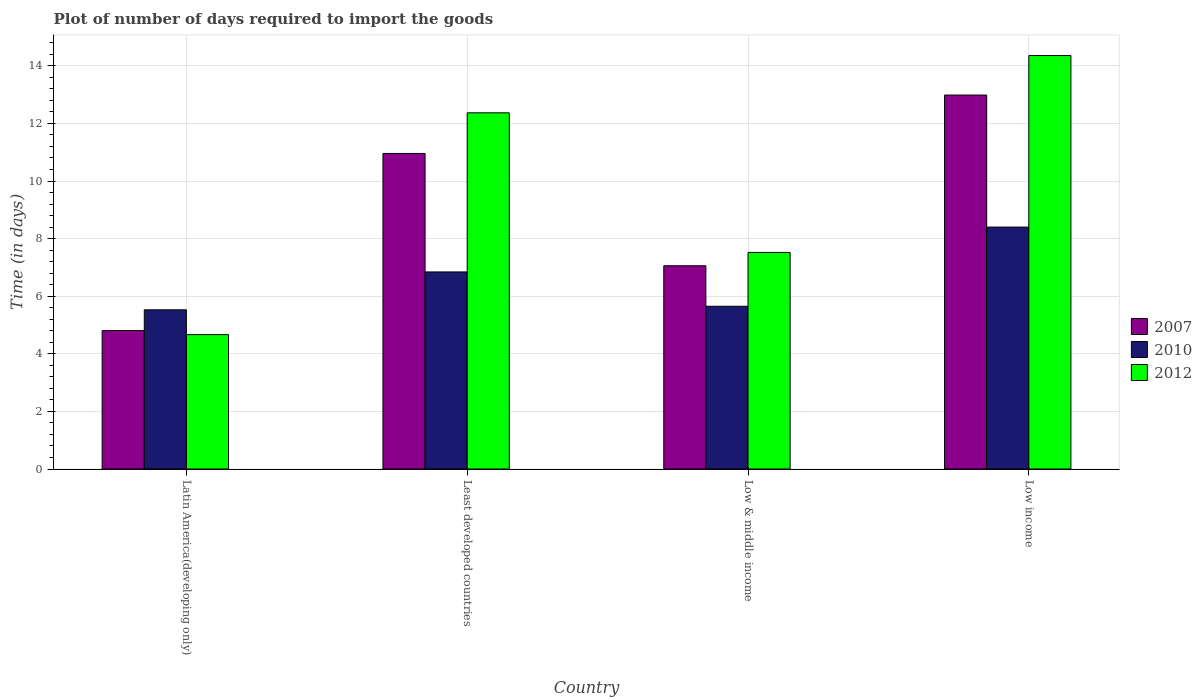How many groups of bars are there?
Your response must be concise. 4. Are the number of bars per tick equal to the number of legend labels?
Offer a very short reply. Yes. How many bars are there on the 4th tick from the left?
Make the answer very short. 3. In how many cases, is the number of bars for a given country not equal to the number of legend labels?
Ensure brevity in your answer.  0. What is the time required to import goods in 2012 in Least developed countries?
Give a very brief answer. 12.37. Across all countries, what is the maximum time required to import goods in 2012?
Keep it short and to the point. 14.36. Across all countries, what is the minimum time required to import goods in 2007?
Your response must be concise. 4.81. In which country was the time required to import goods in 2012 minimum?
Your response must be concise. Latin America(developing only). What is the total time required to import goods in 2012 in the graph?
Keep it short and to the point. 38.91. What is the difference between the time required to import goods in 2007 in Least developed countries and that in Low & middle income?
Your response must be concise. 3.9. What is the difference between the time required to import goods in 2012 in Latin America(developing only) and the time required to import goods in 2010 in Low income?
Give a very brief answer. -3.73. What is the average time required to import goods in 2010 per country?
Give a very brief answer. 6.61. What is the difference between the time required to import goods of/in 2007 and time required to import goods of/in 2012 in Low income?
Your answer should be very brief. -1.37. In how many countries, is the time required to import goods in 2007 greater than 12.4 days?
Your answer should be very brief. 1. What is the ratio of the time required to import goods in 2012 in Latin America(developing only) to that in Low income?
Offer a very short reply. 0.33. What is the difference between the highest and the second highest time required to import goods in 2010?
Your answer should be very brief. 2.75. What is the difference between the highest and the lowest time required to import goods in 2012?
Make the answer very short. 9.69. What does the 2nd bar from the left in Latin America(developing only) represents?
Make the answer very short. 2010. How many bars are there?
Keep it short and to the point. 12. How many countries are there in the graph?
Make the answer very short. 4. What is the difference between two consecutive major ticks on the Y-axis?
Give a very brief answer. 2. Are the values on the major ticks of Y-axis written in scientific E-notation?
Offer a very short reply. No. Does the graph contain grids?
Provide a succinct answer. Yes. How many legend labels are there?
Keep it short and to the point. 3. What is the title of the graph?
Your response must be concise. Plot of number of days required to import the goods. What is the label or title of the Y-axis?
Your answer should be compact. Time (in days). What is the Time (in days) of 2007 in Latin America(developing only)?
Keep it short and to the point. 4.81. What is the Time (in days) of 2010 in Latin America(developing only)?
Keep it short and to the point. 5.53. What is the Time (in days) of 2012 in Latin America(developing only)?
Ensure brevity in your answer.  4.67. What is the Time (in days) in 2007 in Least developed countries?
Your answer should be compact. 10.96. What is the Time (in days) in 2010 in Least developed countries?
Give a very brief answer. 6.84. What is the Time (in days) in 2012 in Least developed countries?
Provide a succinct answer. 12.37. What is the Time (in days) in 2007 in Low & middle income?
Your answer should be very brief. 7.06. What is the Time (in days) in 2010 in Low & middle income?
Provide a short and direct response. 5.65. What is the Time (in days) in 2012 in Low & middle income?
Provide a short and direct response. 7.52. What is the Time (in days) in 2007 in Low income?
Offer a very short reply. 12.99. What is the Time (in days) of 2010 in Low income?
Offer a very short reply. 8.4. What is the Time (in days) in 2012 in Low income?
Provide a succinct answer. 14.36. Across all countries, what is the maximum Time (in days) in 2007?
Give a very brief answer. 12.99. Across all countries, what is the maximum Time (in days) of 2010?
Your answer should be compact. 8.4. Across all countries, what is the maximum Time (in days) of 2012?
Give a very brief answer. 14.36. Across all countries, what is the minimum Time (in days) in 2007?
Your response must be concise. 4.81. Across all countries, what is the minimum Time (in days) of 2010?
Keep it short and to the point. 5.53. Across all countries, what is the minimum Time (in days) of 2012?
Offer a very short reply. 4.67. What is the total Time (in days) of 2007 in the graph?
Provide a succinct answer. 35.81. What is the total Time (in days) in 2010 in the graph?
Give a very brief answer. 26.42. What is the total Time (in days) of 2012 in the graph?
Make the answer very short. 38.91. What is the difference between the Time (in days) in 2007 in Latin America(developing only) and that in Least developed countries?
Provide a succinct answer. -6.15. What is the difference between the Time (in days) in 2010 in Latin America(developing only) and that in Least developed countries?
Provide a short and direct response. -1.32. What is the difference between the Time (in days) of 2012 in Latin America(developing only) and that in Least developed countries?
Give a very brief answer. -7.7. What is the difference between the Time (in days) in 2007 in Latin America(developing only) and that in Low & middle income?
Ensure brevity in your answer.  -2.25. What is the difference between the Time (in days) of 2010 in Latin America(developing only) and that in Low & middle income?
Offer a very short reply. -0.12. What is the difference between the Time (in days) in 2012 in Latin America(developing only) and that in Low & middle income?
Keep it short and to the point. -2.85. What is the difference between the Time (in days) in 2007 in Latin America(developing only) and that in Low income?
Offer a terse response. -8.18. What is the difference between the Time (in days) in 2010 in Latin America(developing only) and that in Low income?
Your answer should be compact. -2.87. What is the difference between the Time (in days) of 2012 in Latin America(developing only) and that in Low income?
Ensure brevity in your answer.  -9.69. What is the difference between the Time (in days) of 2007 in Least developed countries and that in Low & middle income?
Your answer should be compact. 3.9. What is the difference between the Time (in days) in 2010 in Least developed countries and that in Low & middle income?
Your response must be concise. 1.19. What is the difference between the Time (in days) in 2012 in Least developed countries and that in Low & middle income?
Offer a terse response. 4.85. What is the difference between the Time (in days) of 2007 in Least developed countries and that in Low income?
Make the answer very short. -2.03. What is the difference between the Time (in days) of 2010 in Least developed countries and that in Low income?
Your answer should be compact. -1.56. What is the difference between the Time (in days) in 2012 in Least developed countries and that in Low income?
Ensure brevity in your answer.  -1.99. What is the difference between the Time (in days) in 2007 in Low & middle income and that in Low income?
Provide a short and direct response. -5.93. What is the difference between the Time (in days) in 2010 in Low & middle income and that in Low income?
Give a very brief answer. -2.75. What is the difference between the Time (in days) of 2012 in Low & middle income and that in Low income?
Ensure brevity in your answer.  -6.84. What is the difference between the Time (in days) in 2007 in Latin America(developing only) and the Time (in days) in 2010 in Least developed countries?
Your answer should be compact. -2.04. What is the difference between the Time (in days) of 2007 in Latin America(developing only) and the Time (in days) of 2012 in Least developed countries?
Your response must be concise. -7.56. What is the difference between the Time (in days) of 2010 in Latin America(developing only) and the Time (in days) of 2012 in Least developed countries?
Keep it short and to the point. -6.84. What is the difference between the Time (in days) in 2007 in Latin America(developing only) and the Time (in days) in 2010 in Low & middle income?
Offer a terse response. -0.84. What is the difference between the Time (in days) in 2007 in Latin America(developing only) and the Time (in days) in 2012 in Low & middle income?
Offer a very short reply. -2.71. What is the difference between the Time (in days) in 2010 in Latin America(developing only) and the Time (in days) in 2012 in Low & middle income?
Offer a terse response. -1.99. What is the difference between the Time (in days) of 2007 in Latin America(developing only) and the Time (in days) of 2010 in Low income?
Offer a very short reply. -3.59. What is the difference between the Time (in days) of 2007 in Latin America(developing only) and the Time (in days) of 2012 in Low income?
Your response must be concise. -9.55. What is the difference between the Time (in days) of 2010 in Latin America(developing only) and the Time (in days) of 2012 in Low income?
Offer a very short reply. -8.83. What is the difference between the Time (in days) in 2007 in Least developed countries and the Time (in days) in 2010 in Low & middle income?
Offer a terse response. 5.31. What is the difference between the Time (in days) of 2007 in Least developed countries and the Time (in days) of 2012 in Low & middle income?
Offer a terse response. 3.44. What is the difference between the Time (in days) of 2010 in Least developed countries and the Time (in days) of 2012 in Low & middle income?
Make the answer very short. -0.68. What is the difference between the Time (in days) of 2007 in Least developed countries and the Time (in days) of 2010 in Low income?
Offer a very short reply. 2.56. What is the difference between the Time (in days) in 2007 in Least developed countries and the Time (in days) in 2012 in Low income?
Offer a very short reply. -3.4. What is the difference between the Time (in days) in 2010 in Least developed countries and the Time (in days) in 2012 in Low income?
Offer a very short reply. -7.51. What is the difference between the Time (in days) of 2007 in Low & middle income and the Time (in days) of 2010 in Low income?
Give a very brief answer. -1.34. What is the difference between the Time (in days) of 2007 in Low & middle income and the Time (in days) of 2012 in Low income?
Offer a terse response. -7.3. What is the difference between the Time (in days) in 2010 in Low & middle income and the Time (in days) in 2012 in Low income?
Keep it short and to the point. -8.71. What is the average Time (in days) of 2007 per country?
Your answer should be compact. 8.95. What is the average Time (in days) in 2010 per country?
Your answer should be very brief. 6.61. What is the average Time (in days) of 2012 per country?
Your response must be concise. 9.73. What is the difference between the Time (in days) in 2007 and Time (in days) in 2010 in Latin America(developing only)?
Provide a short and direct response. -0.72. What is the difference between the Time (in days) of 2007 and Time (in days) of 2012 in Latin America(developing only)?
Offer a terse response. 0.14. What is the difference between the Time (in days) in 2010 and Time (in days) in 2012 in Latin America(developing only)?
Give a very brief answer. 0.86. What is the difference between the Time (in days) of 2007 and Time (in days) of 2010 in Least developed countries?
Offer a very short reply. 4.11. What is the difference between the Time (in days) in 2007 and Time (in days) in 2012 in Least developed countries?
Your response must be concise. -1.41. What is the difference between the Time (in days) of 2010 and Time (in days) of 2012 in Least developed countries?
Your response must be concise. -5.52. What is the difference between the Time (in days) of 2007 and Time (in days) of 2010 in Low & middle income?
Your answer should be compact. 1.41. What is the difference between the Time (in days) of 2007 and Time (in days) of 2012 in Low & middle income?
Your response must be concise. -0.46. What is the difference between the Time (in days) of 2010 and Time (in days) of 2012 in Low & middle income?
Ensure brevity in your answer.  -1.87. What is the difference between the Time (in days) in 2007 and Time (in days) in 2010 in Low income?
Offer a terse response. 4.58. What is the difference between the Time (in days) in 2007 and Time (in days) in 2012 in Low income?
Provide a short and direct response. -1.37. What is the difference between the Time (in days) in 2010 and Time (in days) in 2012 in Low income?
Offer a terse response. -5.96. What is the ratio of the Time (in days) in 2007 in Latin America(developing only) to that in Least developed countries?
Offer a terse response. 0.44. What is the ratio of the Time (in days) in 2010 in Latin America(developing only) to that in Least developed countries?
Offer a terse response. 0.81. What is the ratio of the Time (in days) of 2012 in Latin America(developing only) to that in Least developed countries?
Ensure brevity in your answer.  0.38. What is the ratio of the Time (in days) of 2007 in Latin America(developing only) to that in Low & middle income?
Provide a short and direct response. 0.68. What is the ratio of the Time (in days) of 2010 in Latin America(developing only) to that in Low & middle income?
Your response must be concise. 0.98. What is the ratio of the Time (in days) in 2012 in Latin America(developing only) to that in Low & middle income?
Offer a very short reply. 0.62. What is the ratio of the Time (in days) of 2007 in Latin America(developing only) to that in Low income?
Your answer should be very brief. 0.37. What is the ratio of the Time (in days) of 2010 in Latin America(developing only) to that in Low income?
Provide a short and direct response. 0.66. What is the ratio of the Time (in days) of 2012 in Latin America(developing only) to that in Low income?
Give a very brief answer. 0.33. What is the ratio of the Time (in days) of 2007 in Least developed countries to that in Low & middle income?
Your answer should be compact. 1.55. What is the ratio of the Time (in days) in 2010 in Least developed countries to that in Low & middle income?
Provide a succinct answer. 1.21. What is the ratio of the Time (in days) of 2012 in Least developed countries to that in Low & middle income?
Make the answer very short. 1.64. What is the ratio of the Time (in days) in 2007 in Least developed countries to that in Low income?
Provide a succinct answer. 0.84. What is the ratio of the Time (in days) of 2010 in Least developed countries to that in Low income?
Ensure brevity in your answer.  0.81. What is the ratio of the Time (in days) of 2012 in Least developed countries to that in Low income?
Your answer should be compact. 0.86. What is the ratio of the Time (in days) of 2007 in Low & middle income to that in Low income?
Offer a very short reply. 0.54. What is the ratio of the Time (in days) of 2010 in Low & middle income to that in Low income?
Provide a short and direct response. 0.67. What is the ratio of the Time (in days) in 2012 in Low & middle income to that in Low income?
Make the answer very short. 0.52. What is the difference between the highest and the second highest Time (in days) of 2007?
Provide a succinct answer. 2.03. What is the difference between the highest and the second highest Time (in days) of 2010?
Your answer should be very brief. 1.56. What is the difference between the highest and the second highest Time (in days) of 2012?
Provide a succinct answer. 1.99. What is the difference between the highest and the lowest Time (in days) in 2007?
Offer a very short reply. 8.18. What is the difference between the highest and the lowest Time (in days) in 2010?
Your answer should be very brief. 2.87. What is the difference between the highest and the lowest Time (in days) in 2012?
Give a very brief answer. 9.69. 